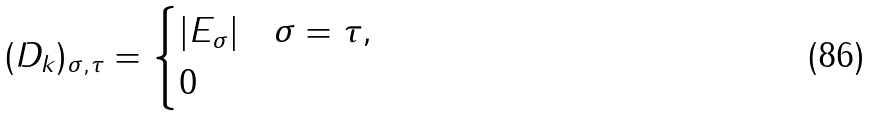Convert formula to latex. <formula><loc_0><loc_0><loc_500><loc_500>( D _ { k } ) _ { \sigma , \tau } = \begin{cases} | E _ { \sigma } | & \sigma = \tau , \\ 0 & \end{cases}</formula> 